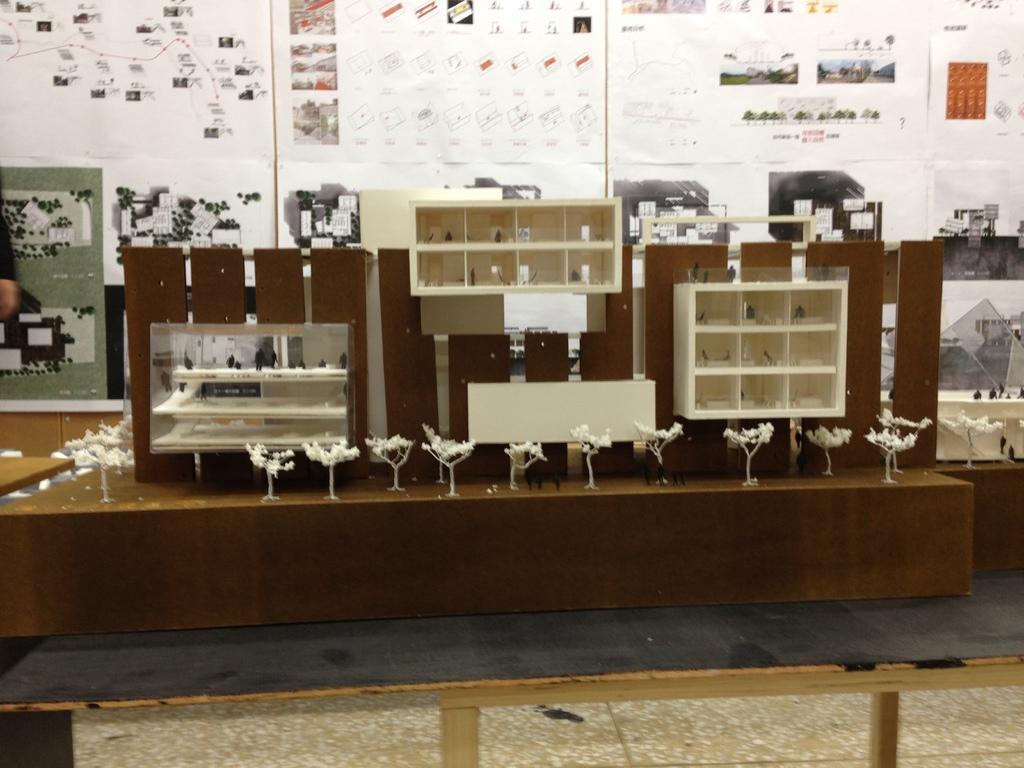Could you give a brief overview of what you see in this image? In this image there are wooden shelves placed on the wooden surface. In the background we can see some informational charts with diagrams and text. 